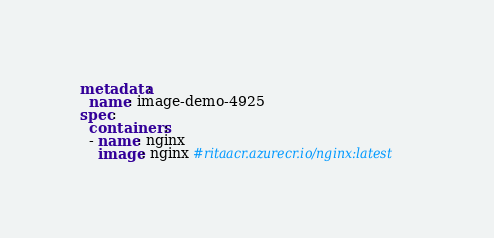<code> <loc_0><loc_0><loc_500><loc_500><_YAML_>metadata:
  name: image-demo-4925
spec:
  containers:
  - name: nginx
    image: nginx #ritaacr.azurecr.io/nginx:latest</code> 